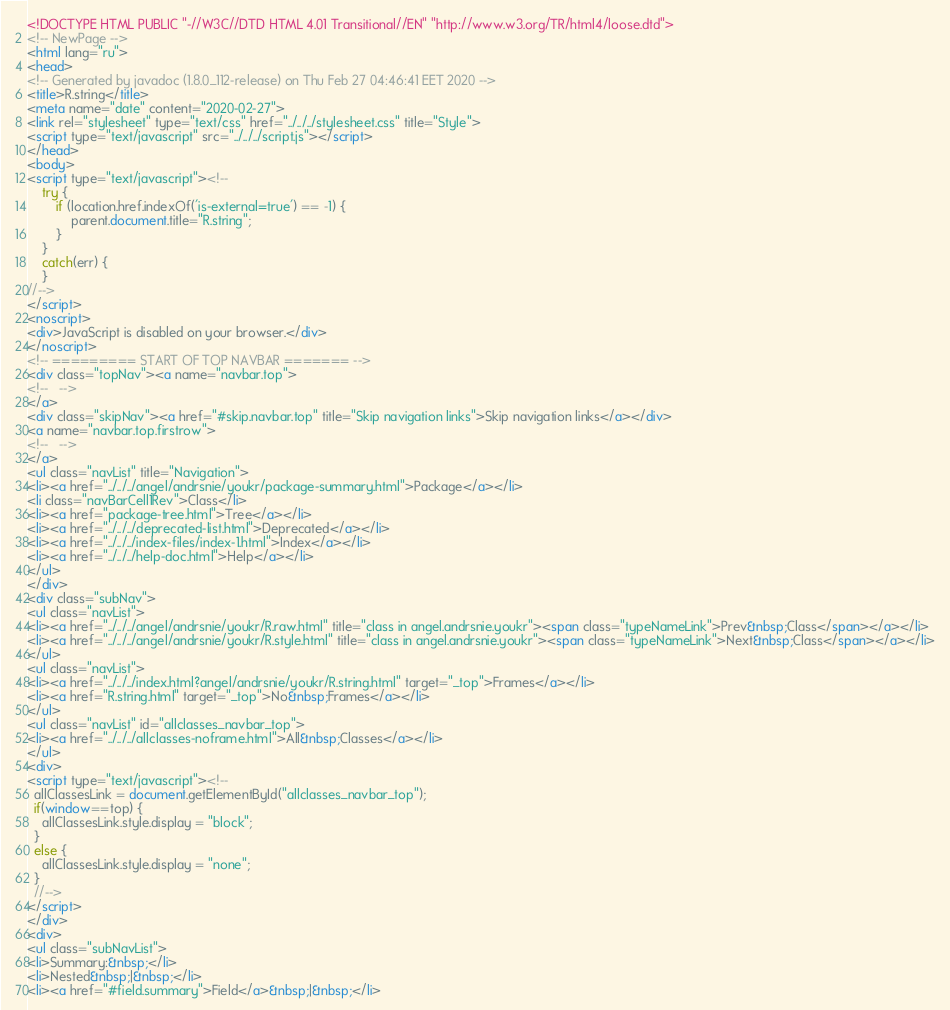Convert code to text. <code><loc_0><loc_0><loc_500><loc_500><_HTML_><!DOCTYPE HTML PUBLIC "-//W3C//DTD HTML 4.01 Transitional//EN" "http://www.w3.org/TR/html4/loose.dtd">
<!-- NewPage -->
<html lang="ru">
<head>
<!-- Generated by javadoc (1.8.0_112-release) on Thu Feb 27 04:46:41 EET 2020 -->
<title>R.string</title>
<meta name="date" content="2020-02-27">
<link rel="stylesheet" type="text/css" href="../../../stylesheet.css" title="Style">
<script type="text/javascript" src="../../../script.js"></script>
</head>
<body>
<script type="text/javascript"><!--
    try {
        if (location.href.indexOf('is-external=true') == -1) {
            parent.document.title="R.string";
        }
    }
    catch(err) {
    }
//-->
</script>
<noscript>
<div>JavaScript is disabled on your browser.</div>
</noscript>
<!-- ========= START OF TOP NAVBAR ======= -->
<div class="topNav"><a name="navbar.top">
<!--   -->
</a>
<div class="skipNav"><a href="#skip.navbar.top" title="Skip navigation links">Skip navigation links</a></div>
<a name="navbar.top.firstrow">
<!--   -->
</a>
<ul class="navList" title="Navigation">
<li><a href="../../../angel/andrsnie/youkr/package-summary.html">Package</a></li>
<li class="navBarCell1Rev">Class</li>
<li><a href="package-tree.html">Tree</a></li>
<li><a href="../../../deprecated-list.html">Deprecated</a></li>
<li><a href="../../../index-files/index-1.html">Index</a></li>
<li><a href="../../../help-doc.html">Help</a></li>
</ul>
</div>
<div class="subNav">
<ul class="navList">
<li><a href="../../../angel/andrsnie/youkr/R.raw.html" title="class in angel.andrsnie.youkr"><span class="typeNameLink">Prev&nbsp;Class</span></a></li>
<li><a href="../../../angel/andrsnie/youkr/R.style.html" title="class in angel.andrsnie.youkr"><span class="typeNameLink">Next&nbsp;Class</span></a></li>
</ul>
<ul class="navList">
<li><a href="../../../index.html?angel/andrsnie/youkr/R.string.html" target="_top">Frames</a></li>
<li><a href="R.string.html" target="_top">No&nbsp;Frames</a></li>
</ul>
<ul class="navList" id="allclasses_navbar_top">
<li><a href="../../../allclasses-noframe.html">All&nbsp;Classes</a></li>
</ul>
<div>
<script type="text/javascript"><!--
  allClassesLink = document.getElementById("allclasses_navbar_top");
  if(window==top) {
    allClassesLink.style.display = "block";
  }
  else {
    allClassesLink.style.display = "none";
  }
  //-->
</script>
</div>
<div>
<ul class="subNavList">
<li>Summary:&nbsp;</li>
<li>Nested&nbsp;|&nbsp;</li>
<li><a href="#field.summary">Field</a>&nbsp;|&nbsp;</li></code> 